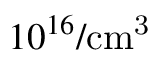Convert formula to latex. <formula><loc_0><loc_0><loc_500><loc_500>1 0 ^ { 1 6 } / c m ^ { 3 }</formula> 